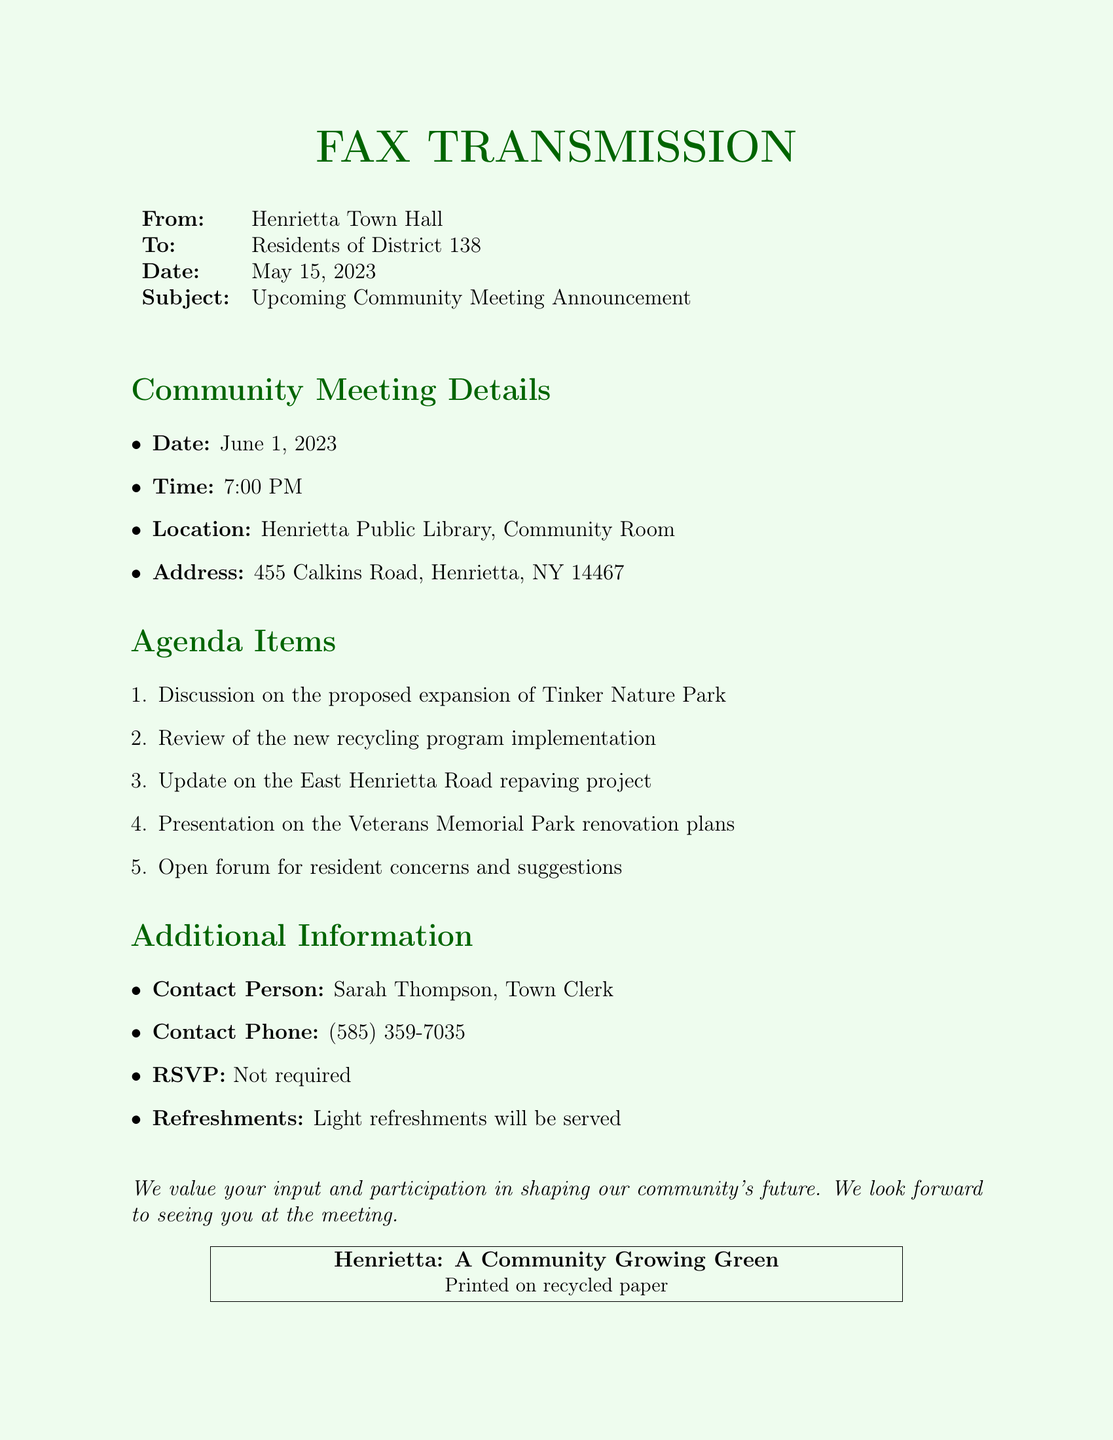What is the date of the community meeting? The date of the community meeting is stated in the document.
Answer: June 1, 2023 What time does the community meeting start? The meeting's starting time is clearly mentioned.
Answer: 7:00 PM Where is the community meeting being held? The location of the meeting is specified in the document.
Answer: Henrietta Public Library, Community Room Who is the contact person for the meeting? The document identifies the contact person with their name.
Answer: Sarah Thompson What is one of the agenda items? One example of an agenda item can be found in the list provided in the document.
Answer: Proposed expansion of Tinker Nature Park Is RSVP required for the meeting? The document explicitly states whether RSVP is necessary or not.
Answer: Not required What type of refreshments will be served? The document describes the type of refreshments that will be available at the meeting.
Answer: Light refreshments What is the address of the meeting location? The document provides the complete address where the meeting will take place.
Answer: 455 Calkins Road, Henrietta, NY 14467 What is the subject of the fax? The subject line of the fax indicates the main topic.
Answer: Upcoming Community Meeting Announcement 